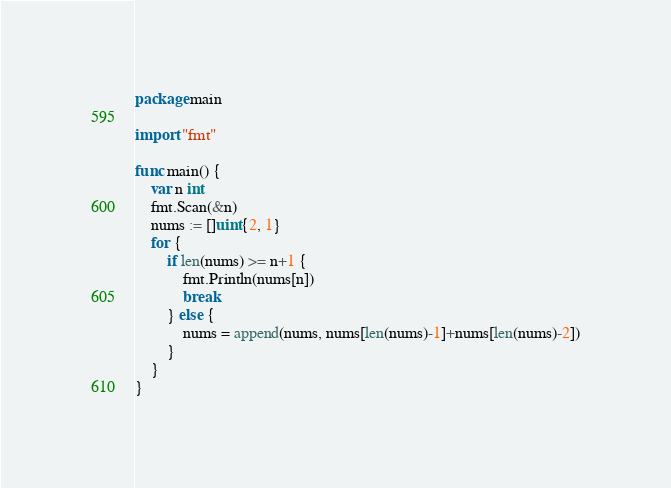Convert code to text. <code><loc_0><loc_0><loc_500><loc_500><_Go_>package main

import "fmt"

func main() {
	var n int
	fmt.Scan(&n)
	nums := []uint{2, 1}
	for {
		if len(nums) >= n+1 {
			fmt.Println(nums[n])
			break
		} else {
			nums = append(nums, nums[len(nums)-1]+nums[len(nums)-2])
		}
	}
}
</code> 